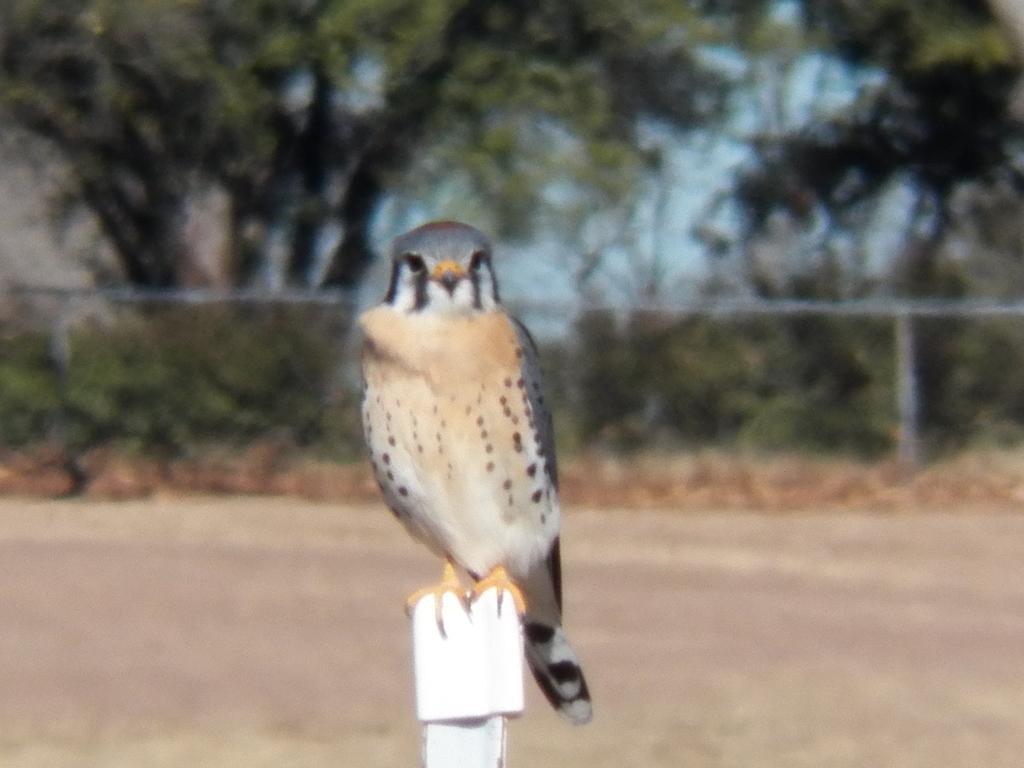How would you summarize this image in a sentence or two? In this image I can see a white colour thing in the front and on it I can see a bird. In the background I can see few poles, number of trees and I can see this image is little bit blurry in the background. 